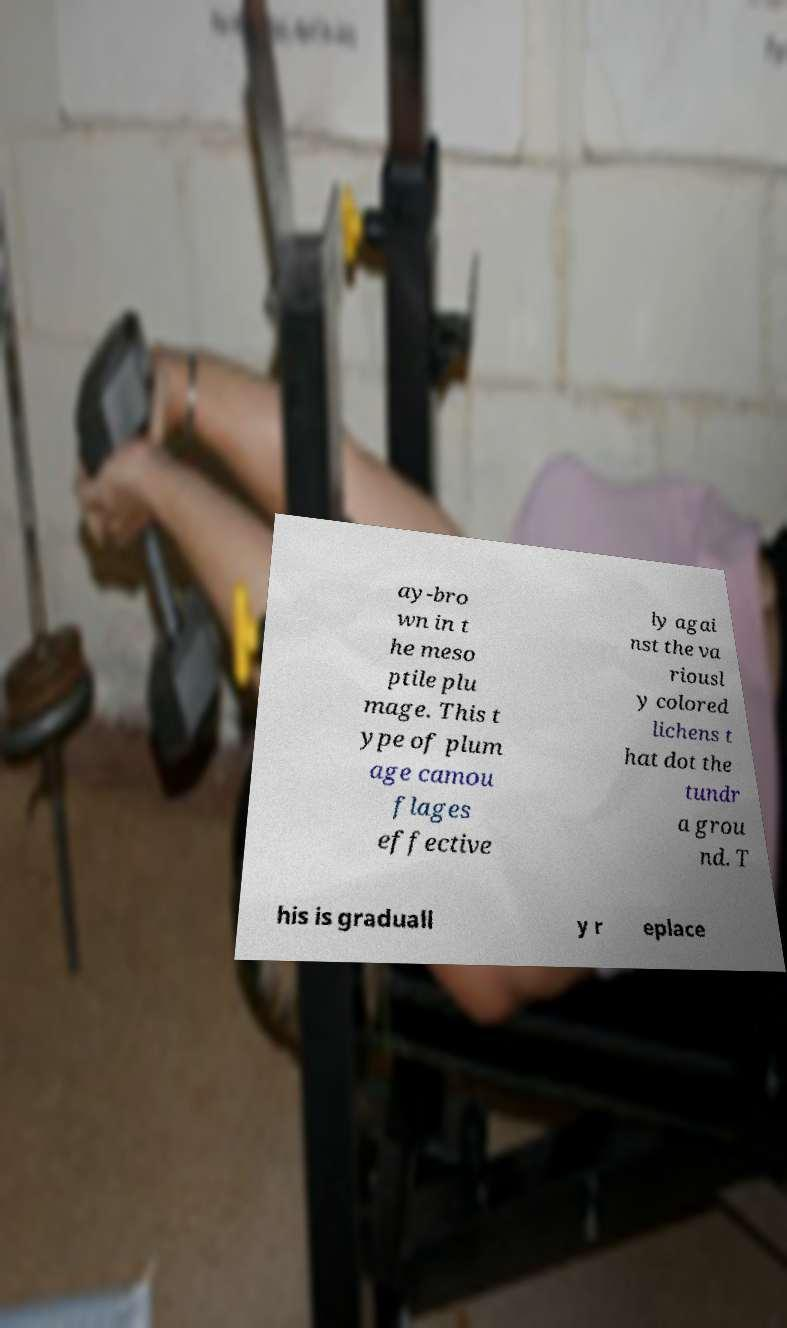For documentation purposes, I need the text within this image transcribed. Could you provide that? ay-bro wn in t he meso ptile plu mage. This t ype of plum age camou flages effective ly agai nst the va riousl y colored lichens t hat dot the tundr a grou nd. T his is graduall y r eplace 